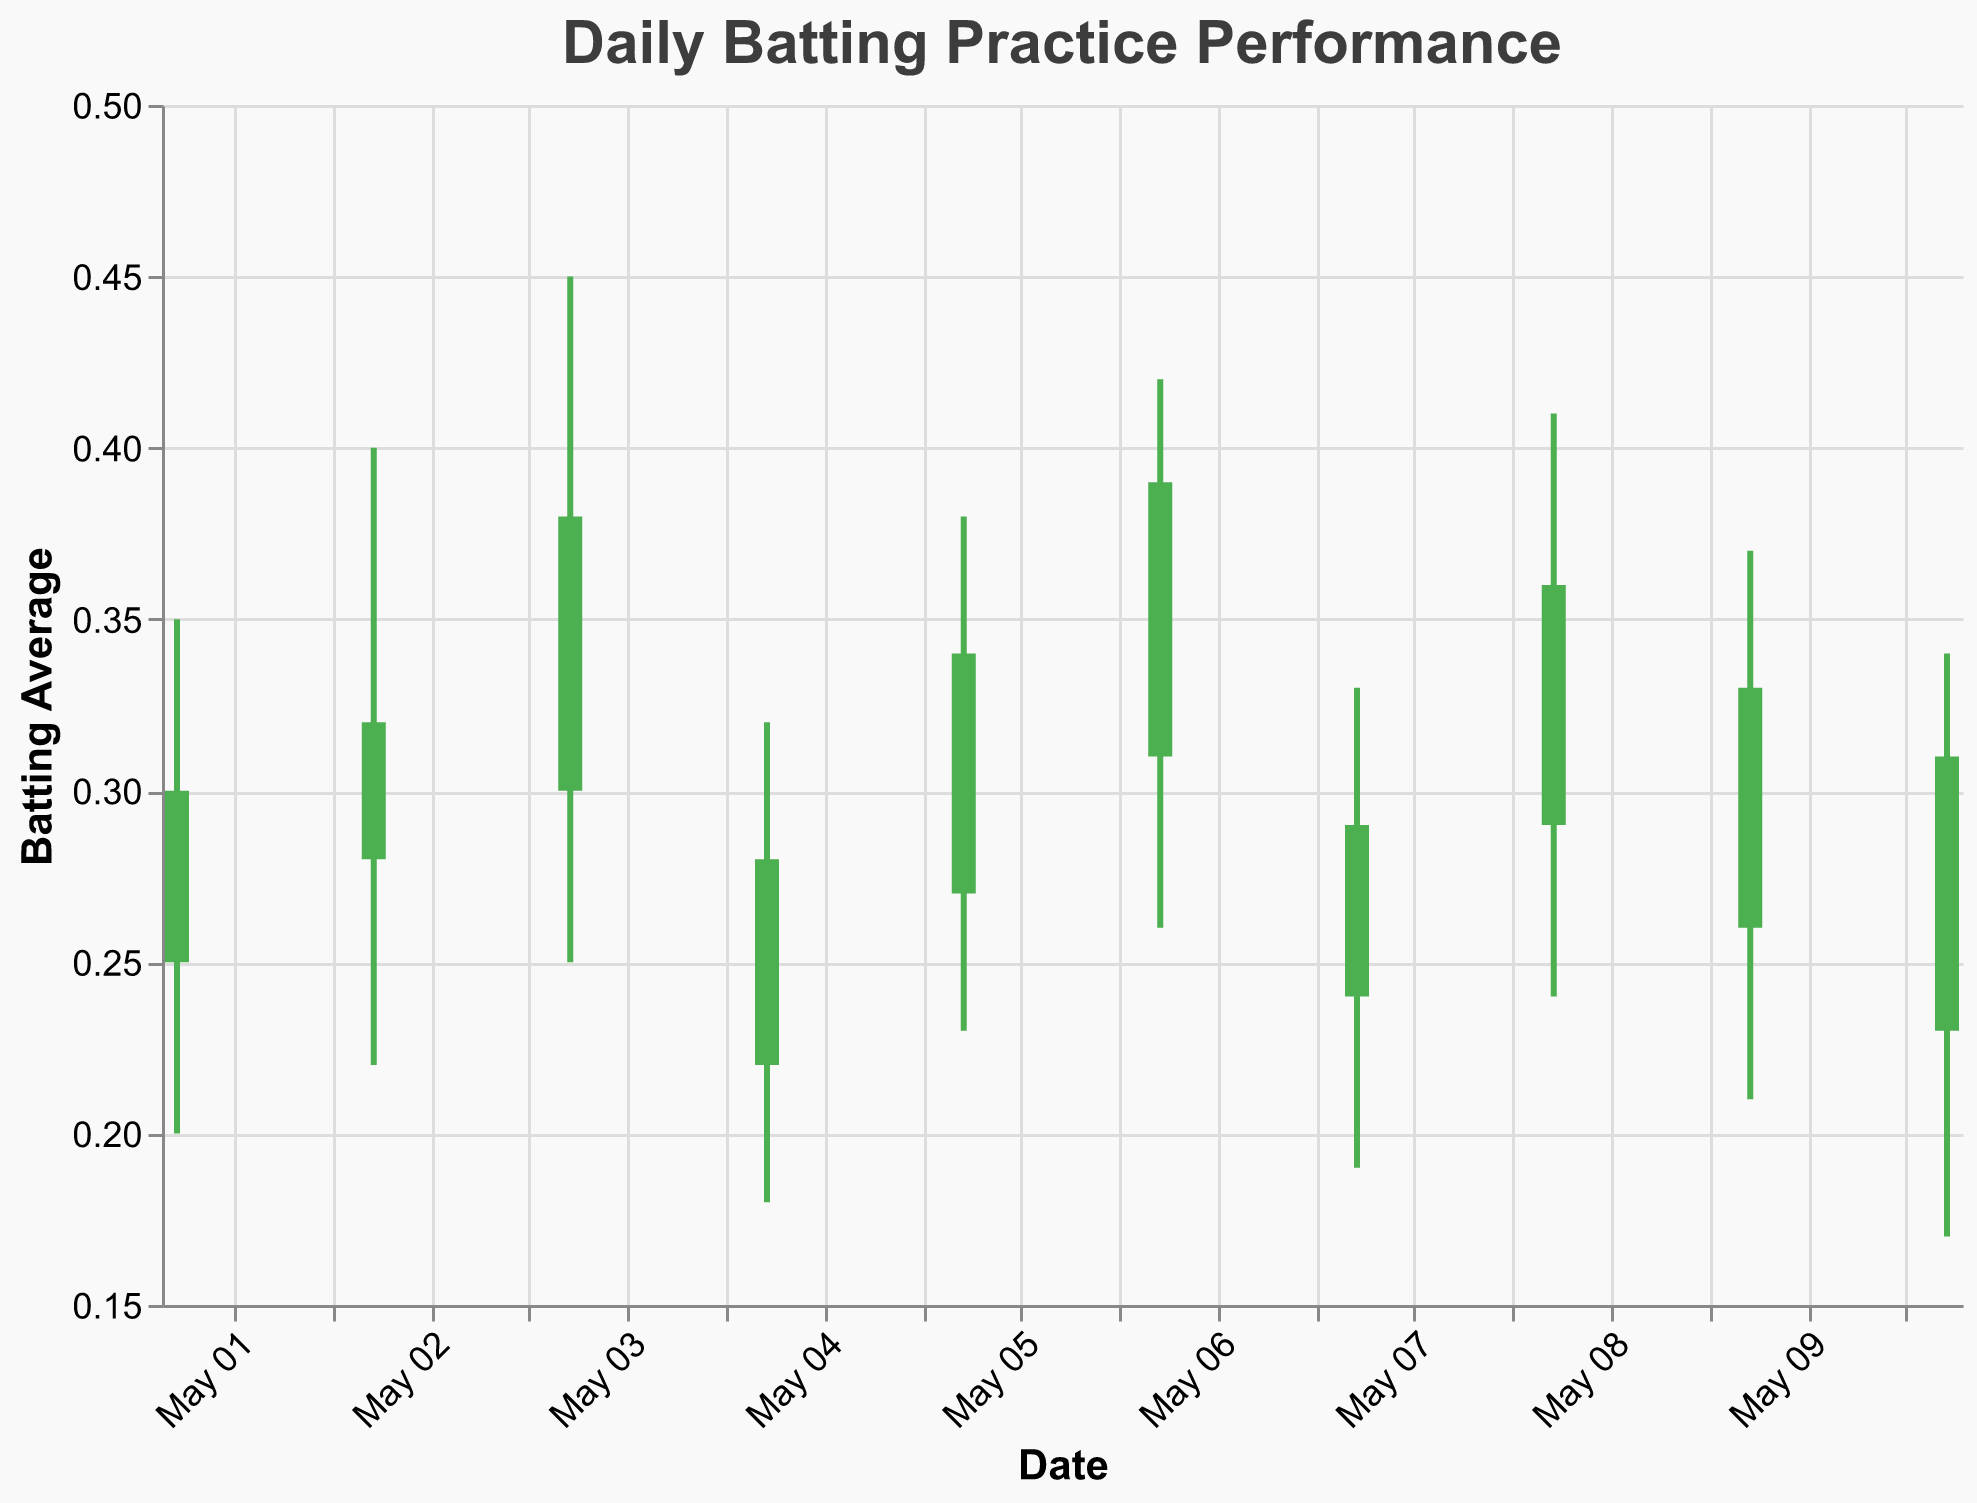What is the title of the chart? The title is prominently displayed at the top of the chart, written in large, bold text. It summarizes the content or main focus of the figure.
Answer: Daily Batting Practice Performance How many players' performance data are shown in the chart? By looking at the number of distinct data points along the x-axis (dates) and combining it with the tooltip for player names, you can count the entries.
Answer: 10 Which player had the highest 'High' batting average during the period? By reviewing each high-point on the chart or checking the tooltip values, you can determine which player reached the maximum 'High' value. Peter Horvath has the highest 'High' value at 0.450 on May 3rd.
Answer: Peter Horvath On which dates did the 'Close' value decline compared to the 'Open' value? A declining 'Close' value compared to 'Open' is marked in a specific color (e.g., red). By identifying these dates on the chart, we can list them.
Answer: May 4, May 7, May 10 What is the average 'High' batting average during the period? Add all the 'High' values and divide by the number of values to find the average. (0.35 + 0.4 + 0.45 + 0.32 + 0.38 + 0.42 + 0.33 + 0.41 + 0.37 + 0.34) / 10 = 3.77 / 10 = 0.377
Answer: 0.377 Compare the 'Close' values of Jakub Novak and Martin Kovac. Who has the higher value? By checking the 'Close' values for Jakub Novak and Martin Kovac, we can compare them to see that Martin has 0.320 versus Jakub's 0.300.
Answer: Martin Kovac Which day had the highest range between 'High' and 'Low' values? To find the day with the highest range, subtract 'Low' from 'High' for each day and find the maximum difference.
Answer: May 3 What is the average increase or decrease from 'Open' to 'Close' over the period? Calculate the difference between 'Close' and 'Open' for each date, then average these differences:
(0.300-0.250 + 0.320-0.280 + 0.380-0.300 + 0.280-0.220 + 0.340-0.270 + 0.390-0.310 + 0.290-0.240 + 0.360-0.290 + 0.330-0.260 + 0.310-0.230) / 10 = (0.05 + 0.04 + 0.08 + 0.06 + 0.07 + 0.08 + 0.05 + 0.07 + 0.07 + 0.08) / 10 = 0.65 / 10 = 0.065
Answer: 0.065 Which player’s performance showed the largest drop from 'Open' to 'Close' value during the period? Subtract 'Close' from 'Open' for each player and find the maximum negative difference. Juraj Benko had the largest drop (0.310 - 0.230 = 0.080).
Answer: Juraj Benko On what date did Peter Horvath perform, and what were his 'Open' and 'Close' values? By checking the player name in the data or tooltips, we find Peter Horvath on May 3rd with an 'Open' of 0.300 and a 'Close' of 0.380.
Answer: May 3, Open: 0.300, Close: 0.380 